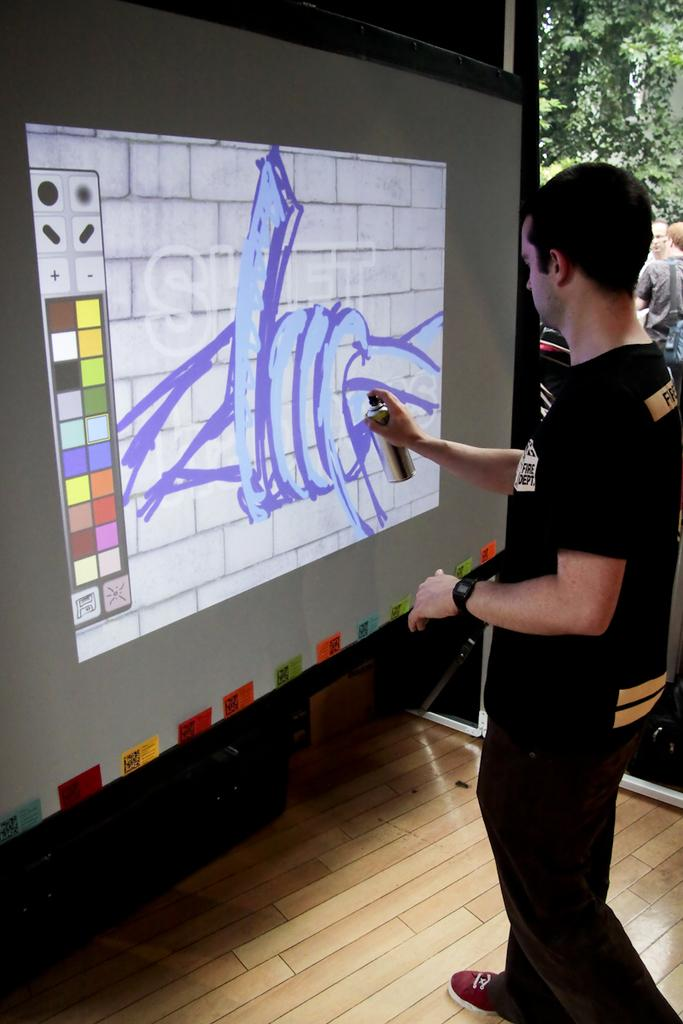What is the man on the right side of the image doing? The man is painting with a spray. What is the man wearing? The man is wearing a black t-shirt, black trousers, and black shoes. What can be seen on the left side of the image? There is a painting display on the left side of the image. What type of leather is the man using to control the painting process in the image? There is no leather or control mechanism mentioned in the image; the man is using a spray to paint. 